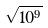<formula> <loc_0><loc_0><loc_500><loc_500>\sqrt { 1 0 ^ { 9 } }</formula> 